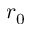<formula> <loc_0><loc_0><loc_500><loc_500>r _ { 0 }</formula> 